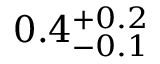<formula> <loc_0><loc_0><loc_500><loc_500>0 . 4 _ { - 0 . 1 } ^ { + 0 . 2 }</formula> 